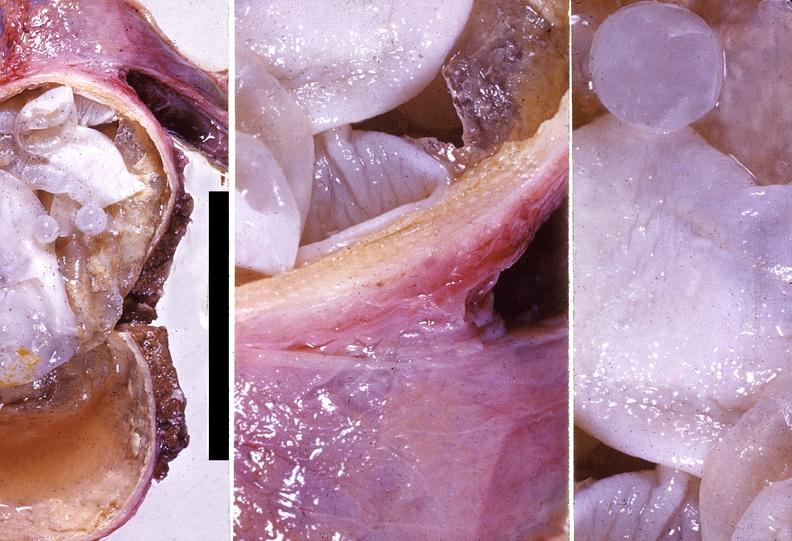what is present?
Answer the question using a single word or phrase. Hepatobiliary 